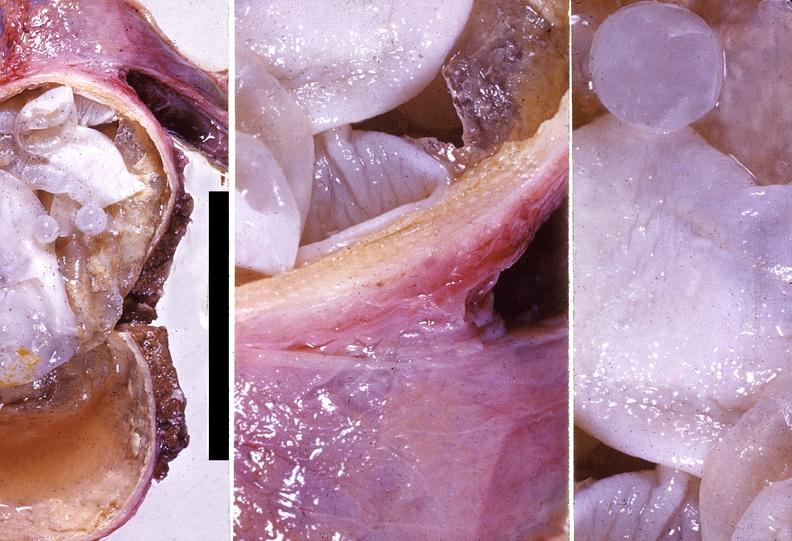what is present?
Answer the question using a single word or phrase. Hepatobiliary 